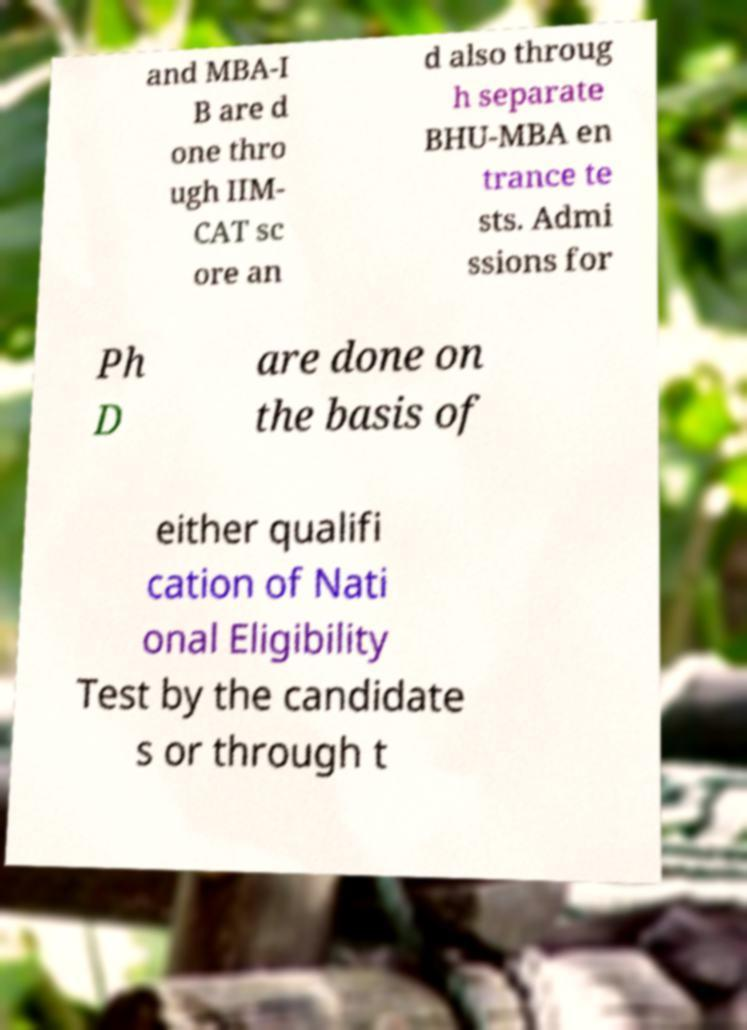There's text embedded in this image that I need extracted. Can you transcribe it verbatim? and MBA-I B are d one thro ugh IIM- CAT sc ore an d also throug h separate BHU-MBA en trance te sts. Admi ssions for Ph D are done on the basis of either qualifi cation of Nati onal Eligibility Test by the candidate s or through t 